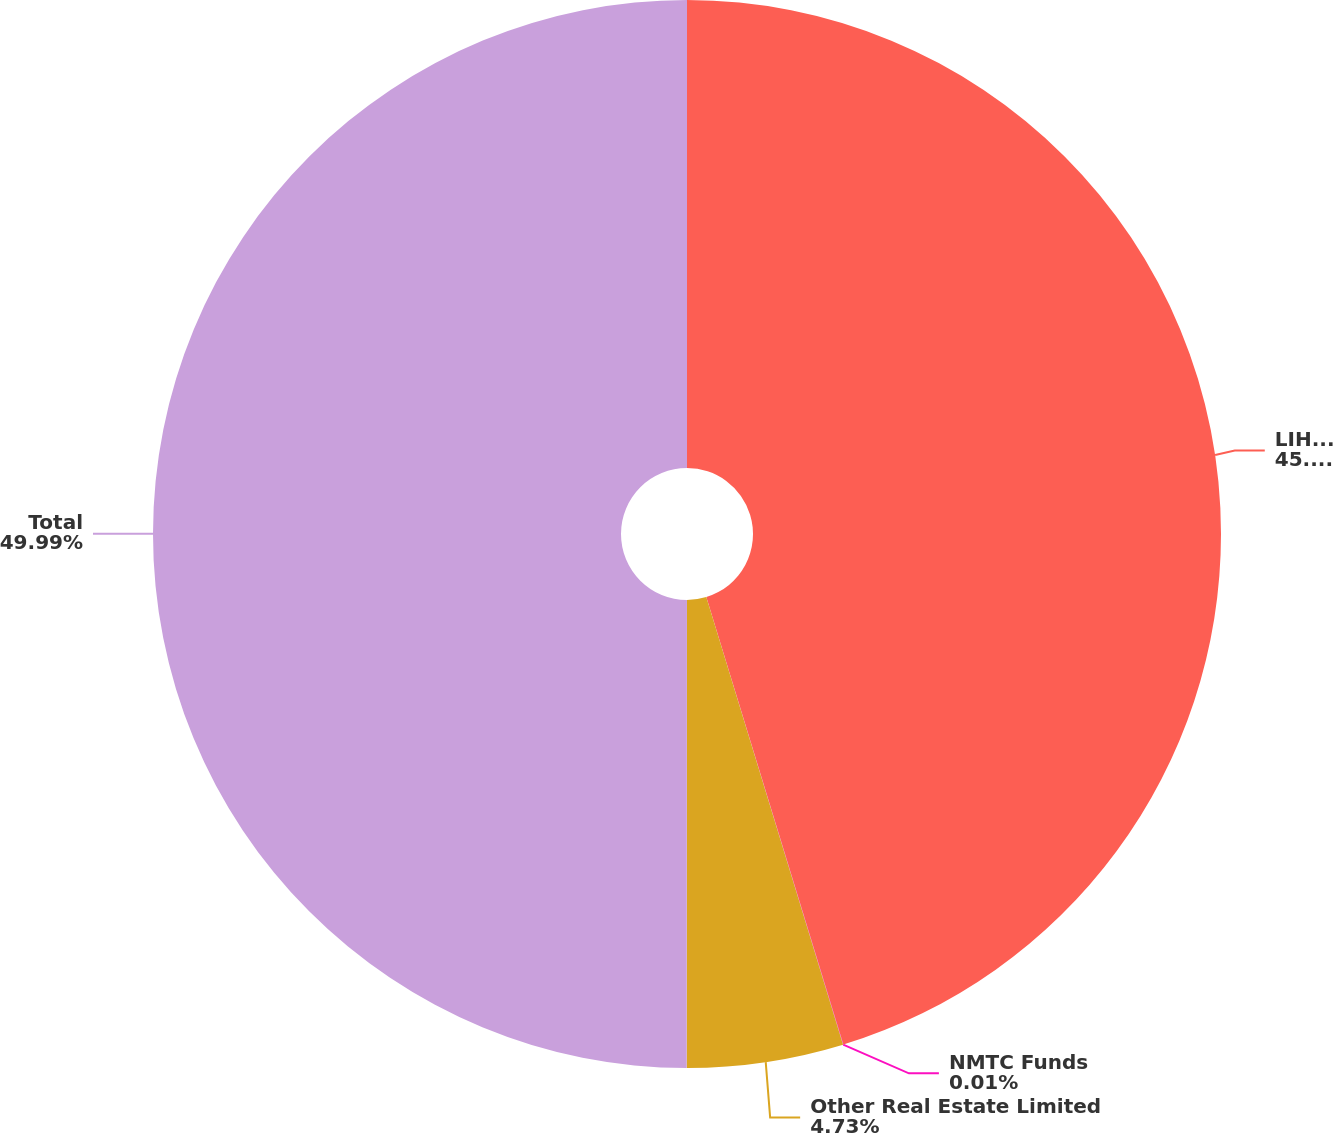Convert chart. <chart><loc_0><loc_0><loc_500><loc_500><pie_chart><fcel>LIHTC Funds<fcel>NMTC Funds<fcel>Other Real Estate Limited<fcel>Total<nl><fcel>45.27%<fcel>0.01%<fcel>4.73%<fcel>49.99%<nl></chart> 